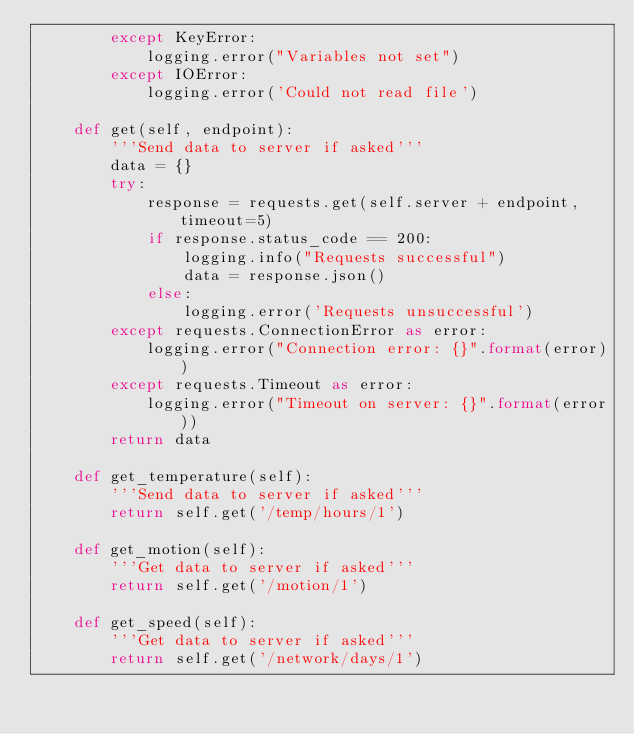Convert code to text. <code><loc_0><loc_0><loc_500><loc_500><_Python_>        except KeyError:
            logging.error("Variables not set")
        except IOError:
            logging.error('Could not read file')

    def get(self, endpoint):
        '''Send data to server if asked'''
        data = {}
        try:
            response = requests.get(self.server + endpoint, timeout=5)
            if response.status_code == 200:
                logging.info("Requests successful")
                data = response.json()
            else:
                logging.error('Requests unsuccessful')
        except requests.ConnectionError as error:
            logging.error("Connection error: {}".format(error))
        except requests.Timeout as error:
            logging.error("Timeout on server: {}".format(error))
        return data

    def get_temperature(self):
        '''Send data to server if asked'''
        return self.get('/temp/hours/1')

    def get_motion(self):
        '''Get data to server if asked'''
        return self.get('/motion/1')

    def get_speed(self):
        '''Get data to server if asked'''
        return self.get('/network/days/1')</code> 